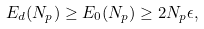<formula> <loc_0><loc_0><loc_500><loc_500>E _ { d } ( N _ { p } ) \geq E _ { 0 } ( N _ { p } ) \geq 2 N _ { p } \epsilon ,</formula> 